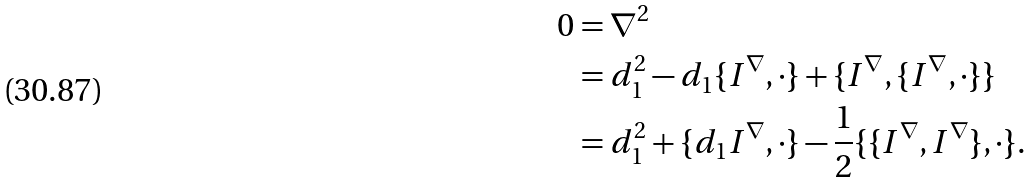Convert formula to latex. <formula><loc_0><loc_0><loc_500><loc_500>0 & = \nabla ^ { 2 } \\ & = d _ { 1 } ^ { 2 } - d _ { 1 } \{ I ^ { \nabla } , \cdot \} + \{ I ^ { \nabla } , \{ I ^ { \nabla } , \cdot \} \} \\ & = d _ { 1 } ^ { 2 } + \{ d _ { 1 } I ^ { \nabla } , \cdot \} - \frac { 1 } { 2 } \{ \{ I ^ { \nabla } , I ^ { \nabla } \} , \cdot \} .</formula> 